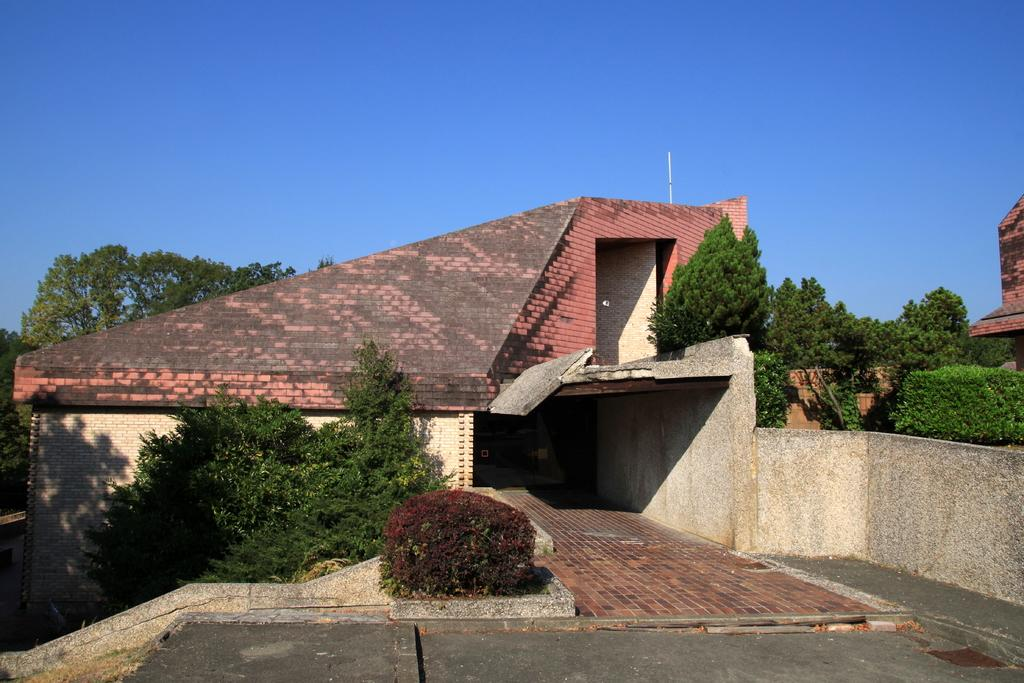What type of structure is visible in the image? There is a house in the image. What is located in front of the house? There are plants and a path in front of the house. What is located behind the house? There are trees behind the house. What is visible in the background of the image? The sky is visible in the image. What type of thread is being used to create the wilderness in the image? There is no thread or wilderness present in the image; it features a house with plants, a path, trees, and the sky. 